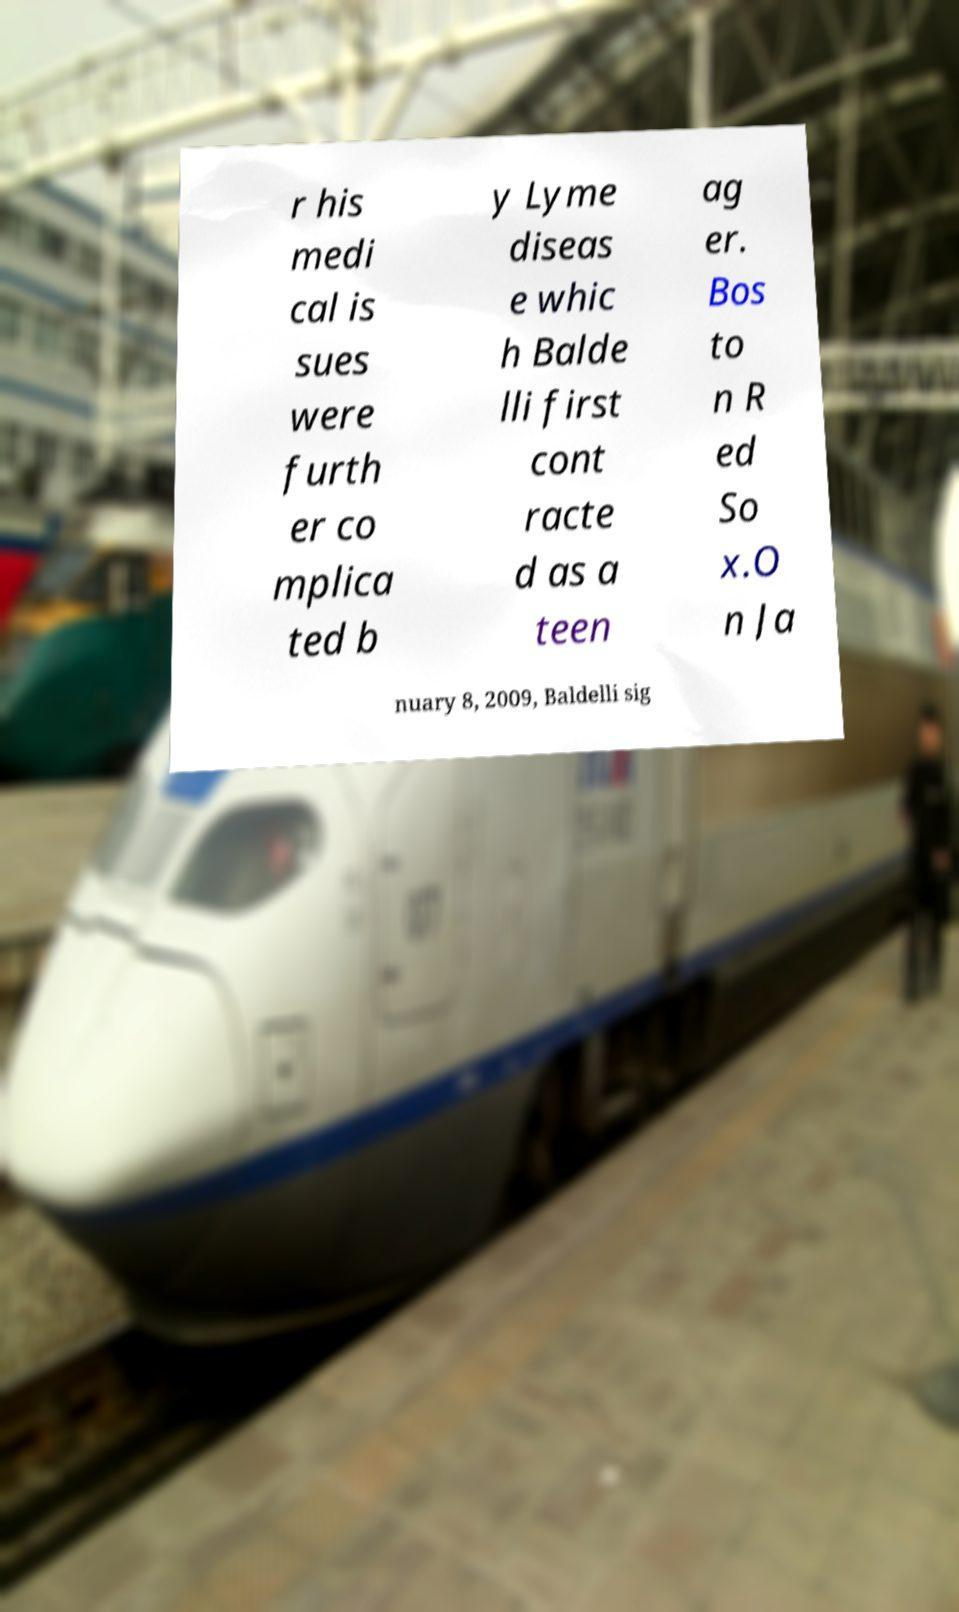Can you accurately transcribe the text from the provided image for me? r his medi cal is sues were furth er co mplica ted b y Lyme diseas e whic h Balde lli first cont racte d as a teen ag er. Bos to n R ed So x.O n Ja nuary 8, 2009, Baldelli sig 